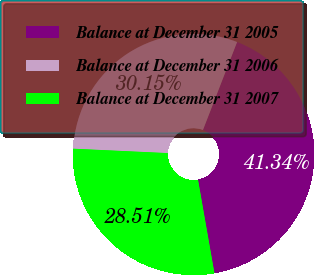Convert chart. <chart><loc_0><loc_0><loc_500><loc_500><pie_chart><fcel>Balance at December 31 2005<fcel>Balance at December 31 2006<fcel>Balance at December 31 2007<nl><fcel>41.34%<fcel>30.15%<fcel>28.51%<nl></chart> 